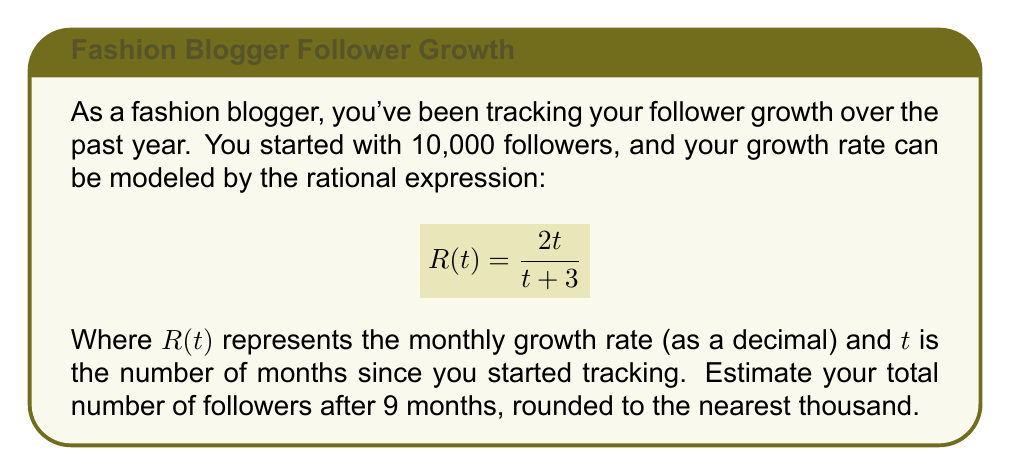What is the answer to this math problem? Let's approach this step-by-step:

1) First, we need to calculate the growth rate at 9 months:
   $$R(9) = \frac{2(9)}{9 + 3} = \frac{18}{12} = 1.5 = 150\%$$

2) This means that after 9 months, your monthly growth rate is 150%.

3) To calculate the total growth over 9 months, we need to compound this rate:
   $$(1 + 1.5)^9 = 2.5^9 \approx 3815.63$$

4) This means your follower count has grown by approximately 3815.63 times.

5) To get the final follower count, multiply the initial followers by this growth:
   $$10,000 * 3815.63 = 38,156,300$$

6) Rounding to the nearest thousand:
   $$38,156,300 \approx 38,156,000$$
Answer: 38,156,000 followers 